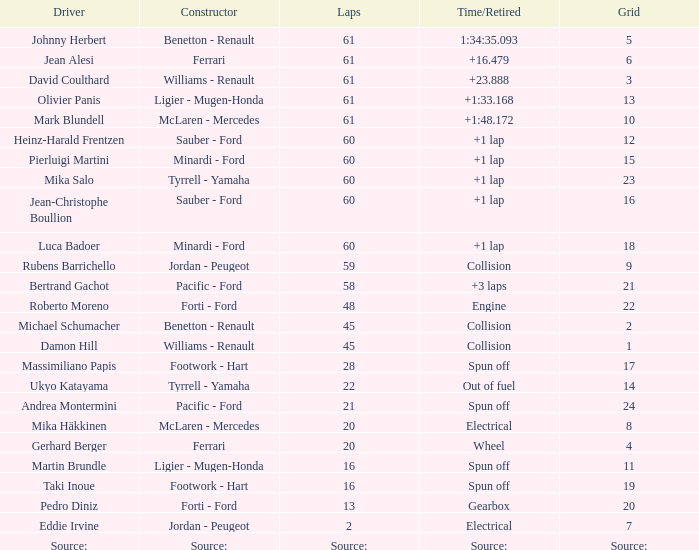What's the time/retired for a grid of 14? Out of fuel. 